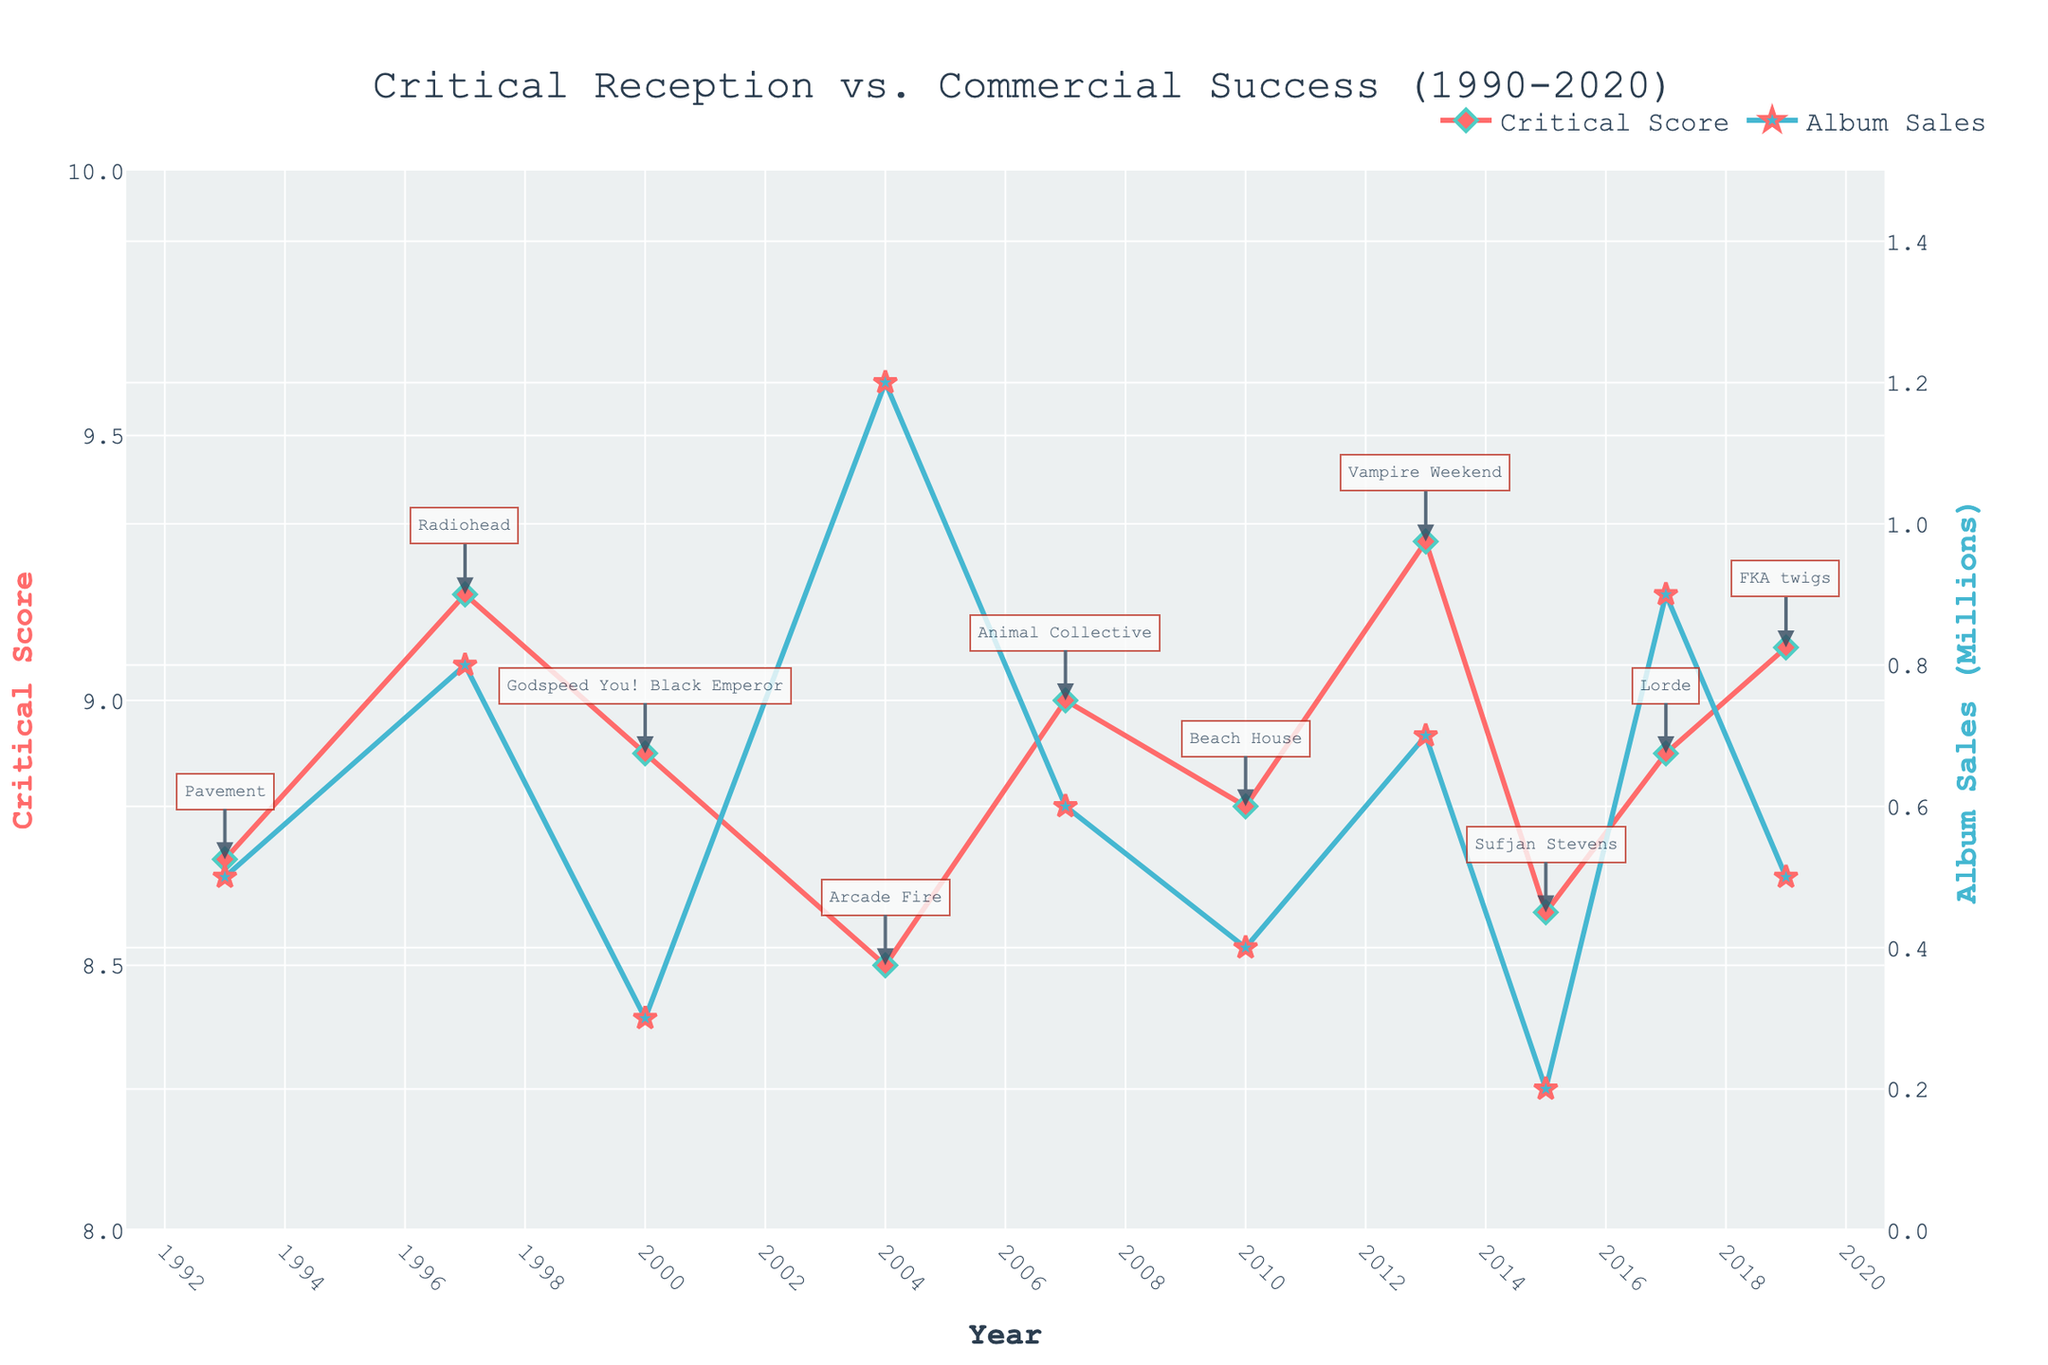What is the trend of critical score for independent artists from 1990 to 2020? Observing the line chart for "Critical Score," the trend shows that the critical scores generally range between 8.5 and 9.3, with some fluctuations but overall high scores throughout the years. The scores peak in 2013 at 9.3 with Vampire Weekend.
Answer: Generally high with some fluctuations Which artist received the highest critical score and in which year? Looking at the annotations and the highest point on the "Critical Score" line, Vampire Weekend received the highest critical score of 9.3 in 2013.
Answer: Vampire Weekend in 2013 Which artist had the lowest album sales despite having a high critical score? By identifying the lowest data point on the "Album Sales" line, Sufjan Stevens in 2015 had low album sales of 0.2 million despite having a relatively high critical score of 8.6.
Answer: Sufjan Stevens in 2015 Which year had the closest values between critical score and album sales? Reviewing the chart, 1997 (Radiohead) appears to have close values with a critical score of 9.2 and album sales of 0.8 million. The difference is less compared to other years.
Answer: 1997 with Radiohead How did Arcade Fire's critical reception compare to their commercial success in 2004? Find Arcade Fire on the chart in 2004; they had a critical score of 8.5 and album sales of 1.2 million. This indicates higher commercial success relative to their critical reception.
Answer: Higher commercial success Which color represents the critical score and which one represents the album sales? By the colors of the lines in the chart, the red line represents "Critical Score," and the blue line represents "Album Sales."
Answer: Red for Critical Score, Blue for Album Sales What is the total number of data points shown in the chart? By counting the markers on each line (Critical Score and Album Sales), there are 10 data points for each, indicating a total of 10 distinct years/artists represented.
Answer: 10 In which year did an artist receive a critical score higher than 9 but have album sales less than 0.8 million? From the critical score line, 1997 (Radiohead with 9.2), 2007 (Animal Collective with 9.0), and 2019 (FKA twigs with 9.1) had critical scores higher than 9. Among these, 2019 (FKA twigs) had album sales of 0.5 million, which is less than 0.8 million.
Answer: 2019 with FKA twigs What is the average critical score for the years presented in the chart? Adding the critical scores (8.7 + 9.2 + 8.9 + 8.5 + 9.0 + 8.8 + 9.3 + 8.6 + 8.9 + 9.1) and dividing by the number of years (10) gives an average score of 8.9.
Answer: 8.9 